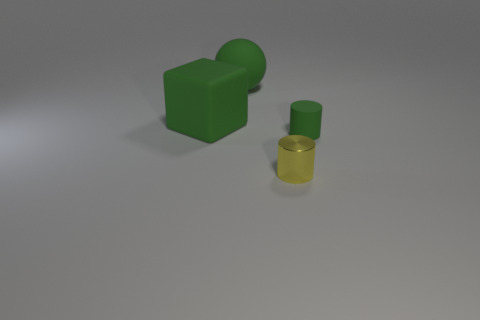There is a object that is both on the left side of the metallic cylinder and in front of the sphere; what is its color?
Offer a terse response. Green. Are there any yellow blocks that have the same size as the matte cylinder?
Offer a terse response. No. There is a green ball to the right of the thing left of the large ball; how big is it?
Your answer should be compact. Large. Are there fewer green spheres in front of the sphere than yellow metallic balls?
Give a very brief answer. No. Do the cube and the metal object have the same color?
Your answer should be very brief. No. How big is the yellow shiny cylinder?
Ensure brevity in your answer.  Small. How many spheres are the same color as the tiny rubber thing?
Your response must be concise. 1. Is there a small matte object that is in front of the cylinder in front of the tiny cylinder right of the small yellow metallic cylinder?
Provide a succinct answer. No. What is the shape of the rubber thing that is the same size as the metal cylinder?
Make the answer very short. Cylinder. How many tiny things are either green rubber cubes or yellow cylinders?
Ensure brevity in your answer.  1. 